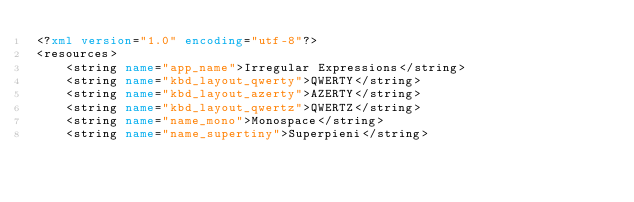<code> <loc_0><loc_0><loc_500><loc_500><_XML_><?xml version="1.0" encoding="utf-8"?>
<resources>
    <string name="app_name">Irregular Expressions</string>
    <string name="kbd_layout_qwerty">QWERTY</string>
    <string name="kbd_layout_azerty">AZERTY</string>
    <string name="kbd_layout_qwertz">QWERTZ</string>
    <string name="name_mono">Monospace</string>
    <string name="name_supertiny">Superpieni</string></code> 